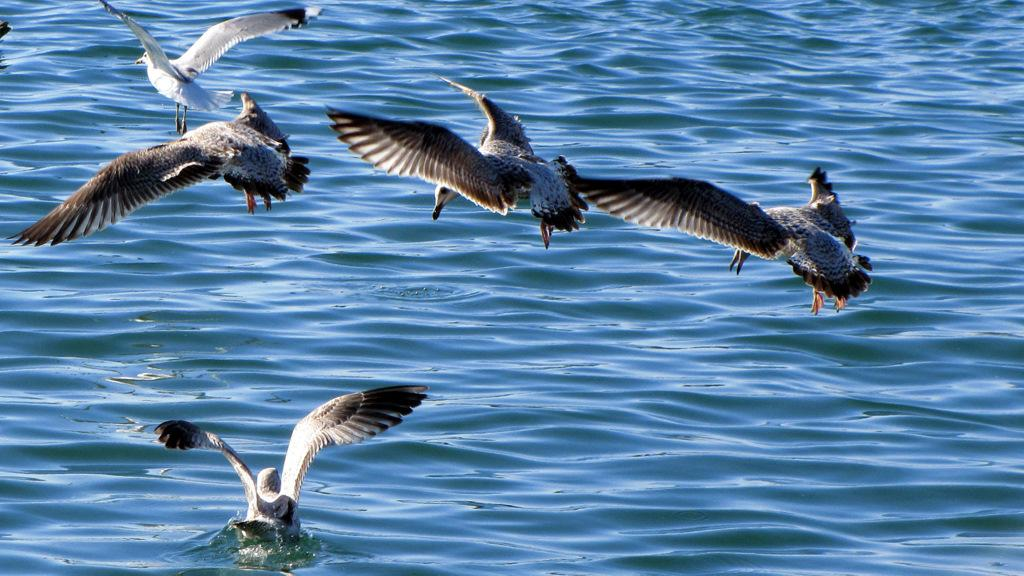Where was the picture taken? The picture was taken outside. What can be seen in the sky in the image? There are birds flying in the image. Can you describe the bird in the water body? Yes, there is a bird in a water body in the image. What type of riddle is the bird in the water body trying to solve in the image? There is no indication in the image that the bird is trying to solve a riddle. 